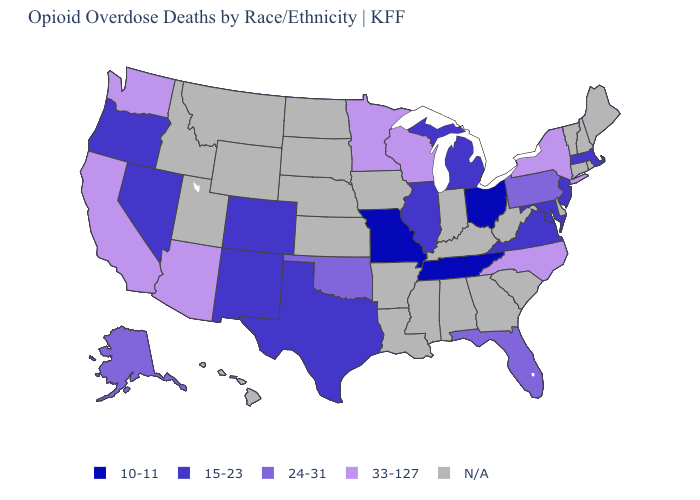Name the states that have a value in the range 24-31?
Answer briefly. Alaska, Florida, Oklahoma, Pennsylvania. What is the value of Nevada?
Answer briefly. 15-23. Which states hav the highest value in the West?
Concise answer only. Arizona, California, Washington. Does the map have missing data?
Short answer required. Yes. Does the first symbol in the legend represent the smallest category?
Concise answer only. Yes. Does the map have missing data?
Short answer required. Yes. What is the highest value in the USA?
Concise answer only. 33-127. What is the value of Mississippi?
Be succinct. N/A. Name the states that have a value in the range 33-127?
Short answer required. Arizona, California, Minnesota, New York, North Carolina, Washington, Wisconsin. What is the value of Washington?
Answer briefly. 33-127. Name the states that have a value in the range 10-11?
Write a very short answer. Missouri, Ohio, Tennessee. How many symbols are there in the legend?
Write a very short answer. 5. What is the lowest value in the MidWest?
Be succinct. 10-11. 